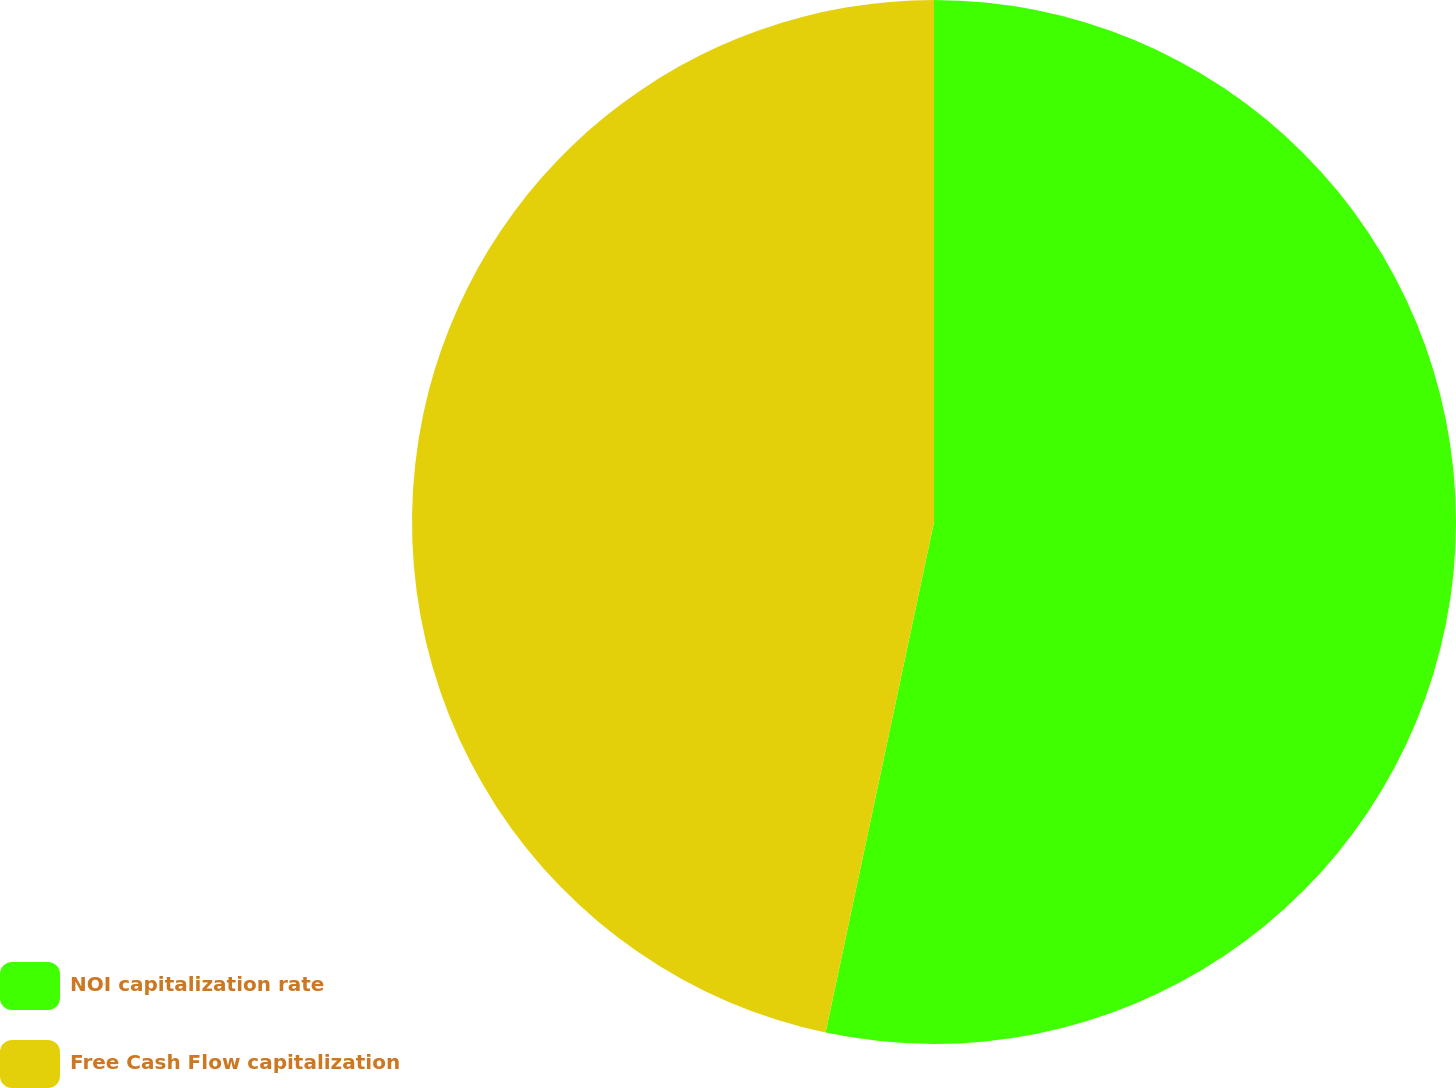Convert chart to OTSL. <chart><loc_0><loc_0><loc_500><loc_500><pie_chart><fcel>NOI capitalization rate<fcel>Free Cash Flow capitalization<nl><fcel>53.33%<fcel>46.67%<nl></chart> 